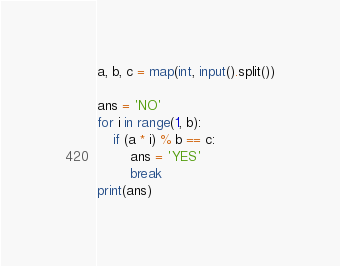<code> <loc_0><loc_0><loc_500><loc_500><_Python_>a, b, c = map(int, input().split())

ans = 'NO'
for i in range(1, b):
    if (a * i) % b == c:
        ans = 'YES'
        break
print(ans)
</code> 